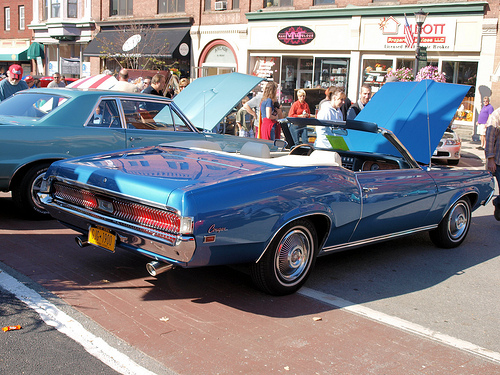<image>
Is there a car in front of the shop? Yes. The car is positioned in front of the shop, appearing closer to the camera viewpoint. 